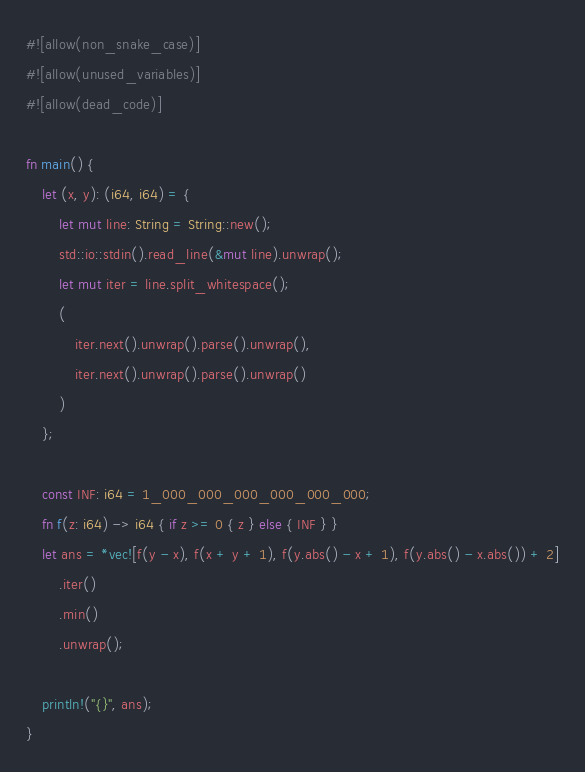<code> <loc_0><loc_0><loc_500><loc_500><_Rust_>#![allow(non_snake_case)]
#![allow(unused_variables)]
#![allow(dead_code)]

fn main() {
    let (x, y): (i64, i64) = {
        let mut line: String = String::new();
        std::io::stdin().read_line(&mut line).unwrap();
        let mut iter = line.split_whitespace();
        (
            iter.next().unwrap().parse().unwrap(),
            iter.next().unwrap().parse().unwrap()
        )
    };

    const INF: i64 = 1_000_000_000_000_000_000;
    fn f(z: i64) -> i64 { if z >= 0 { z } else { INF } }
    let ans = *vec![f(y - x), f(x + y + 1), f(y.abs() - x + 1), f(y.abs() - x.abs()) + 2]
        .iter()
        .min()
        .unwrap();

    println!("{}", ans);
}</code> 